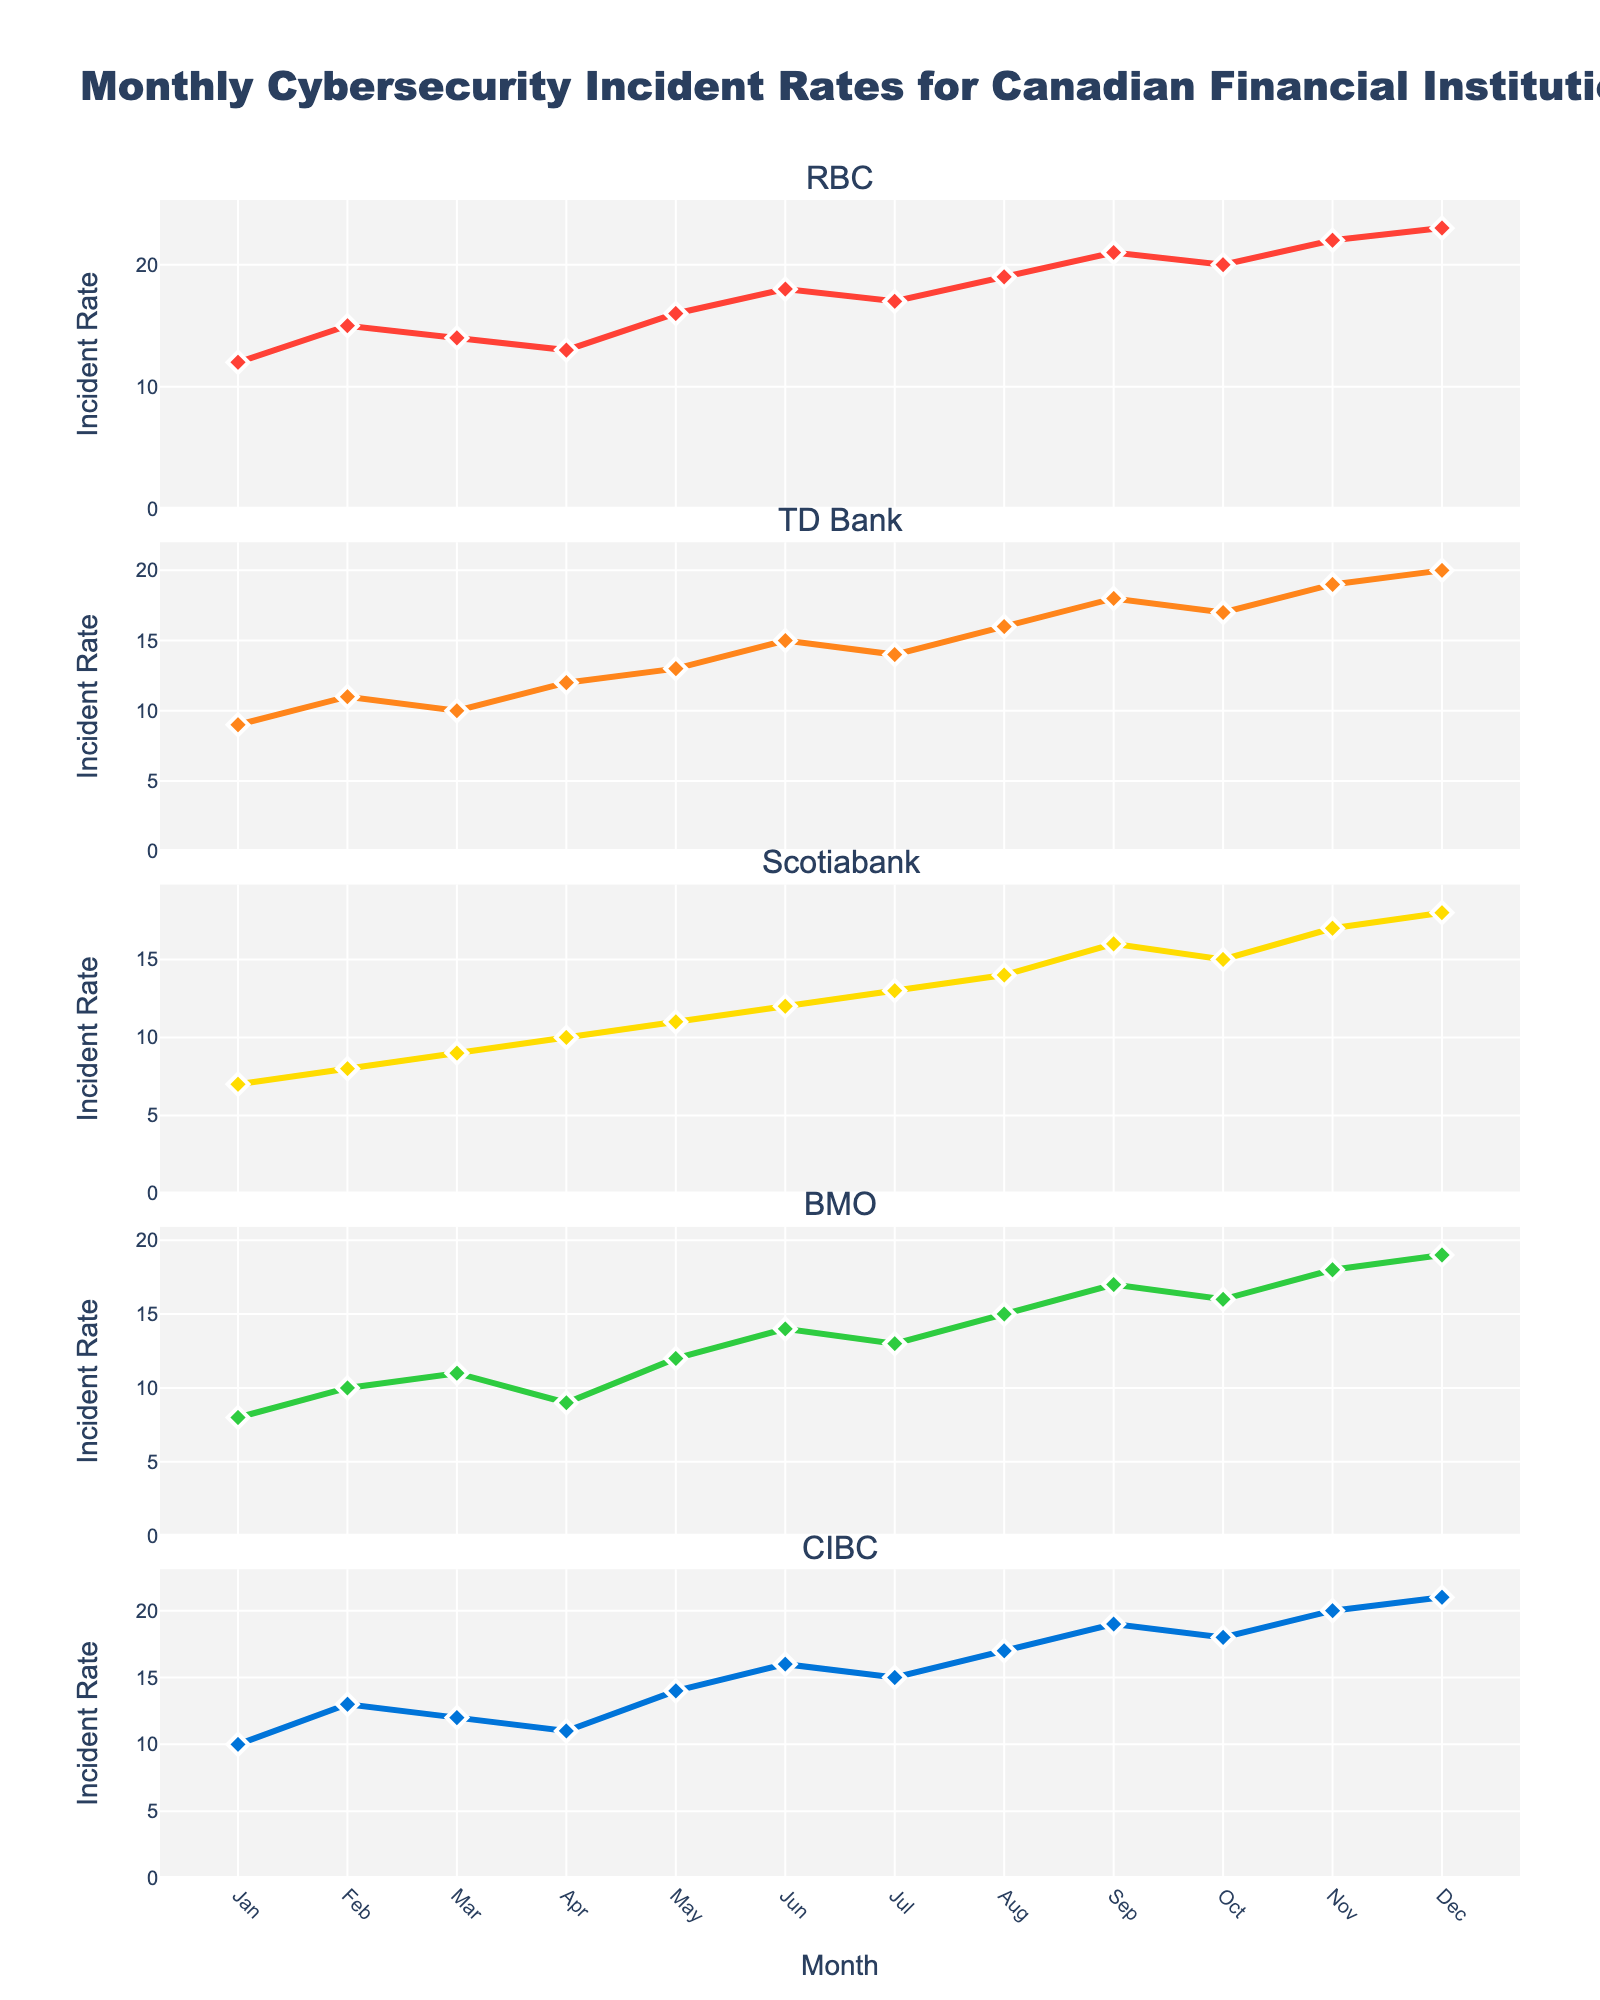What is the overall title of the figure? The title is located at the top of the figure and summarizes the chart's content. It states, "Annual Sales Trends of Top 5 Eco-Friendly Cleaning Products."
Answer: Annual Sales Trends of Top 5 Eco-Friendly Cleaning Products Which product showed the highest sales in 2022? The highest sales in 2022 are shown in the subplot with the highest end value on the vertical axis. "Method Cleaning Spray" has the highest value around 2,180,000$.
Answer: Method Cleaning Spray How did the sales of Grove Co. Glass Cleaner change from 2018 to 2022? We look at Grove Co. Glass Cleaner's subplot. In 2018, sales were 620,000 and increased each year to 1,210,000 by 2022.
Answer: Increased Which product had the lowest sales in 2019? Check each subplot for the sales value in 2019. Grove Co. Glass Cleaner has the lowest value in 2019, which is 680,000.
Answer: Grove Co. Glass Cleaner What is the average sales of Seventh Generation Dish Soap from 2018 to 2022? Sum the sales values for Seventh Generation Dish Soap across all years: 980,000 + 1,050,000 + 1,320,000 + 1,480,000 + 1,620,000 = 6,450,000. Divide by 5 years to find the average: 6,450,000 / 5 = 1,290,000.
Answer: 1,290,000 In which year did Blueland Multi-Surface Cleaner see the largest increase in sales? Calculate the year-to-year differences for Blueland Multi-Surface Cleaner: 2019-2018 (920,000 - 750,000 = 170,000), 2020-2019 (1,150,000 - 920,000 = 230,000), 2021-2020 (1,380,000 - 1,150,000 = 230,000), 2022-2021 (1,590,000 - 1,380,000 = 210,000). The largest increase is from 2019 to 2020 and 2020 to 2021, both by 230,000.
Answer: 2020 and 2021 Between 2019 and 2021, which product had the highest percentage increase in sales? Calculate the percentage increase for each product from 2019 to 2021: 
- Method Cleaning Spray: ((1,950,000 - 1,350,000) / 1,350,000) * 100 = 44.44% 
- Seventh Generation Dish Soap: ((1,480,000 - 1,050,000) / 1,050,000) * 100 = 40.95% 
- Blueland Multi-Surface Cleaner: ((1,380,000 - 920,000) / 920,000) * 100 = 50% 
- Ecover Laundry Detergent: ((1,610,000 - 1,180,000) / 1,180,000) * 100 = 36.44% 
- Grove Co. Glass Cleaner: ((1,050,000 - 680,000) / 680,000) * 100 = 54.41% 
The highest percentage increase is 54.41% for Grove Co. Glass Cleaner.
Answer: Grove Co. Glass Cleaner Which product had consistent sales growth every year from 2018 to 2022? Inspect each subplot for a consistent upward trend without any decreases: All products show consistent growth.
Answer: All products If you were to forecast the product with the fastest-growing trend, which would you choose based on the visual data? Method Cleaning Spray's subplot has the steepest slope over the years, indicating the fastest-growing trend.
Answer: Method Cleaning Spray 